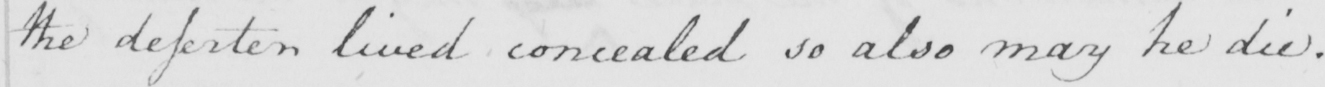What is written in this line of handwriting? the desserter lived concealed so also may he die . 